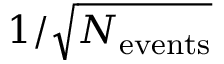<formula> <loc_0><loc_0><loc_500><loc_500>1 / \sqrt { N _ { e v e n t s } }</formula> 